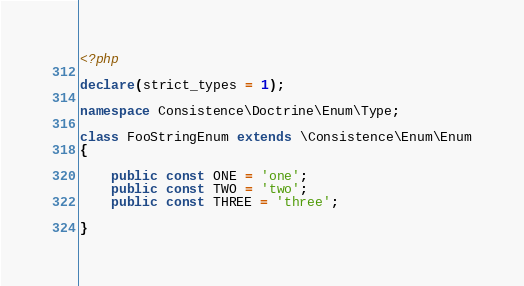<code> <loc_0><loc_0><loc_500><loc_500><_PHP_><?php

declare(strict_types = 1);

namespace Consistence\Doctrine\Enum\Type;

class FooStringEnum extends \Consistence\Enum\Enum
{

	public const ONE = 'one';
	public const TWO = 'two';
	public const THREE = 'three';

}
</code> 